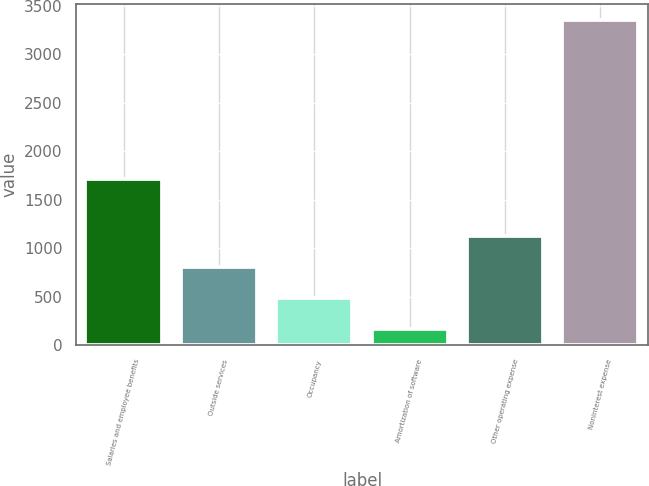Convert chart to OTSL. <chart><loc_0><loc_0><loc_500><loc_500><bar_chart><fcel>Salaries and employee benefits<fcel>Outside services<fcel>Occupancy<fcel>Amortization of software<fcel>Other operating expense<fcel>Noninterest expense<nl><fcel>1714<fcel>806.4<fcel>488.2<fcel>170<fcel>1124.6<fcel>3352<nl></chart> 